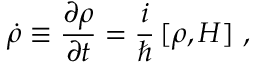<formula> <loc_0><loc_0><loc_500><loc_500>\dot { \rho } \equiv \frac { \partial \rho } { \partial t } = { \frac { i } { } } \, [ \rho , H ] \ ,</formula> 